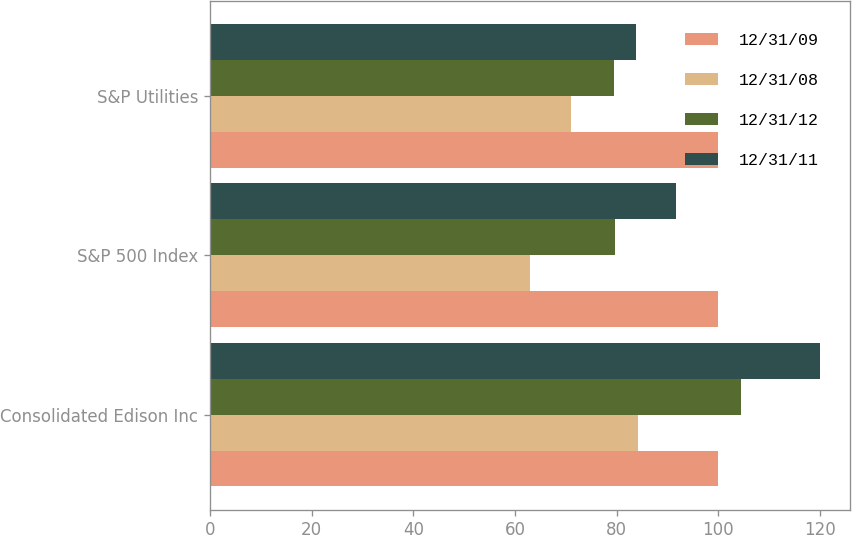<chart> <loc_0><loc_0><loc_500><loc_500><stacked_bar_chart><ecel><fcel>Consolidated Edison Inc<fcel>S&P 500 Index<fcel>S&P Utilities<nl><fcel>12/31/09<fcel>100<fcel>100<fcel>100<nl><fcel>12/31/08<fcel>84.24<fcel>63<fcel>71.02<nl><fcel>12/31/12<fcel>104.37<fcel>79.68<fcel>79.48<nl><fcel>12/31/11<fcel>119.94<fcel>91.68<fcel>83.82<nl></chart> 